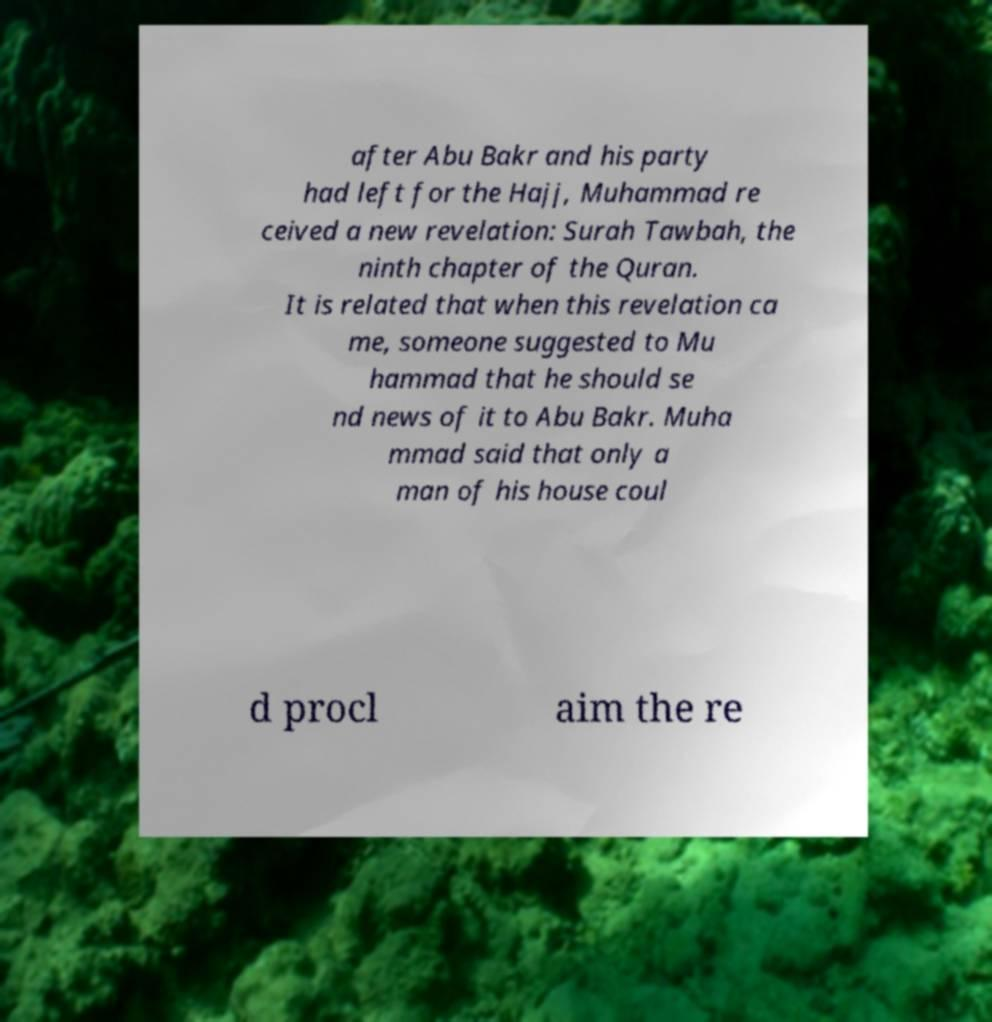For documentation purposes, I need the text within this image transcribed. Could you provide that? after Abu Bakr and his party had left for the Hajj, Muhammad re ceived a new revelation: Surah Tawbah, the ninth chapter of the Quran. It is related that when this revelation ca me, someone suggested to Mu hammad that he should se nd news of it to Abu Bakr. Muha mmad said that only a man of his house coul d procl aim the re 